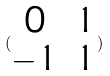<formula> <loc_0><loc_0><loc_500><loc_500>( \begin{matrix} 0 & 1 \\ - 1 & 1 \end{matrix} )</formula> 